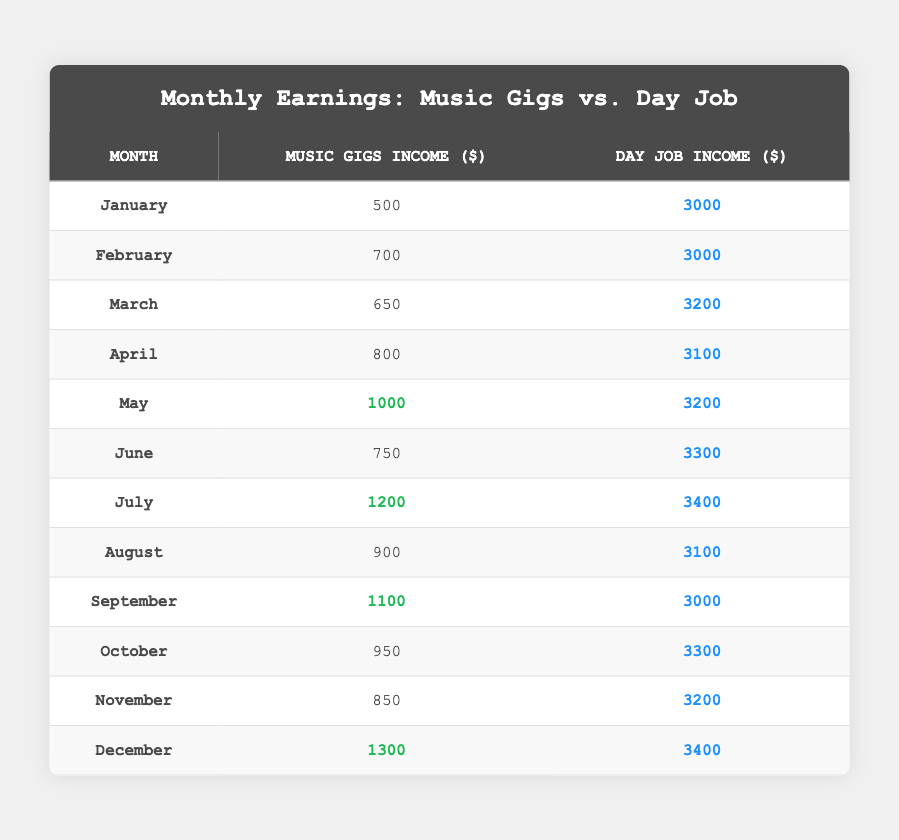What was the highest income from music gigs in a single month? The highest income from music gigs is found in December, where the income is 1300.
Answer: 1300 In which month did the day job income exceed 3400? The day job income only exceeds 3400 in July.
Answer: July What is the average music gigs income for the year? To calculate the average, sum the music gig incomes: (500 + 700 + 650 + 800 + 1000 + 750 + 1200 + 900 + 1100 + 950 + 850 + 1300) = 10300; divide by 12 months gives an average of 10300 / 12 = 858.33.
Answer: 858.33 Did the day job income increase or decrease from January to June? To find this, compare January's income (3000) with June's income (3300); since June's income is higher, it increased.
Answer: Increased Which month had the closest music gigs income to the day job income? Comparing music gig and day job incomes reveals that April (800 vs 3100) and May (1000 vs 3200) have the smallest gaps; thus, May is the month with the closest income to day job income at 1000.
Answer: May What is the total music gigs income for the second half of the year? Sum the music gigs income from July to December: (1200 + 900 + 1100 + 950 + 850 + 1300) = 5350.
Answer: 5350 In which month did the music gigs income surpass 1000 for the first time? Looking at the table, the music gigs income first surpasses 1000 in July.
Answer: July What percentage of the total income for the year does the music gigs income represent? First, total incomes are calculated: music gigs = 10300, day job = 37900, total = 48200. The percentage calculation is (10300 / 48200) * 100 = 21.39%.
Answer: 21.39% Did the music gigs income ever surpass the day job income? Upon reviewing the data, music gigs income never surpassed the day job income.
Answer: No Which month saw a drop in music gigs income compared to the previous month? Comparing consecutive months shows a decrease from July (1200) to August (900).
Answer: August 